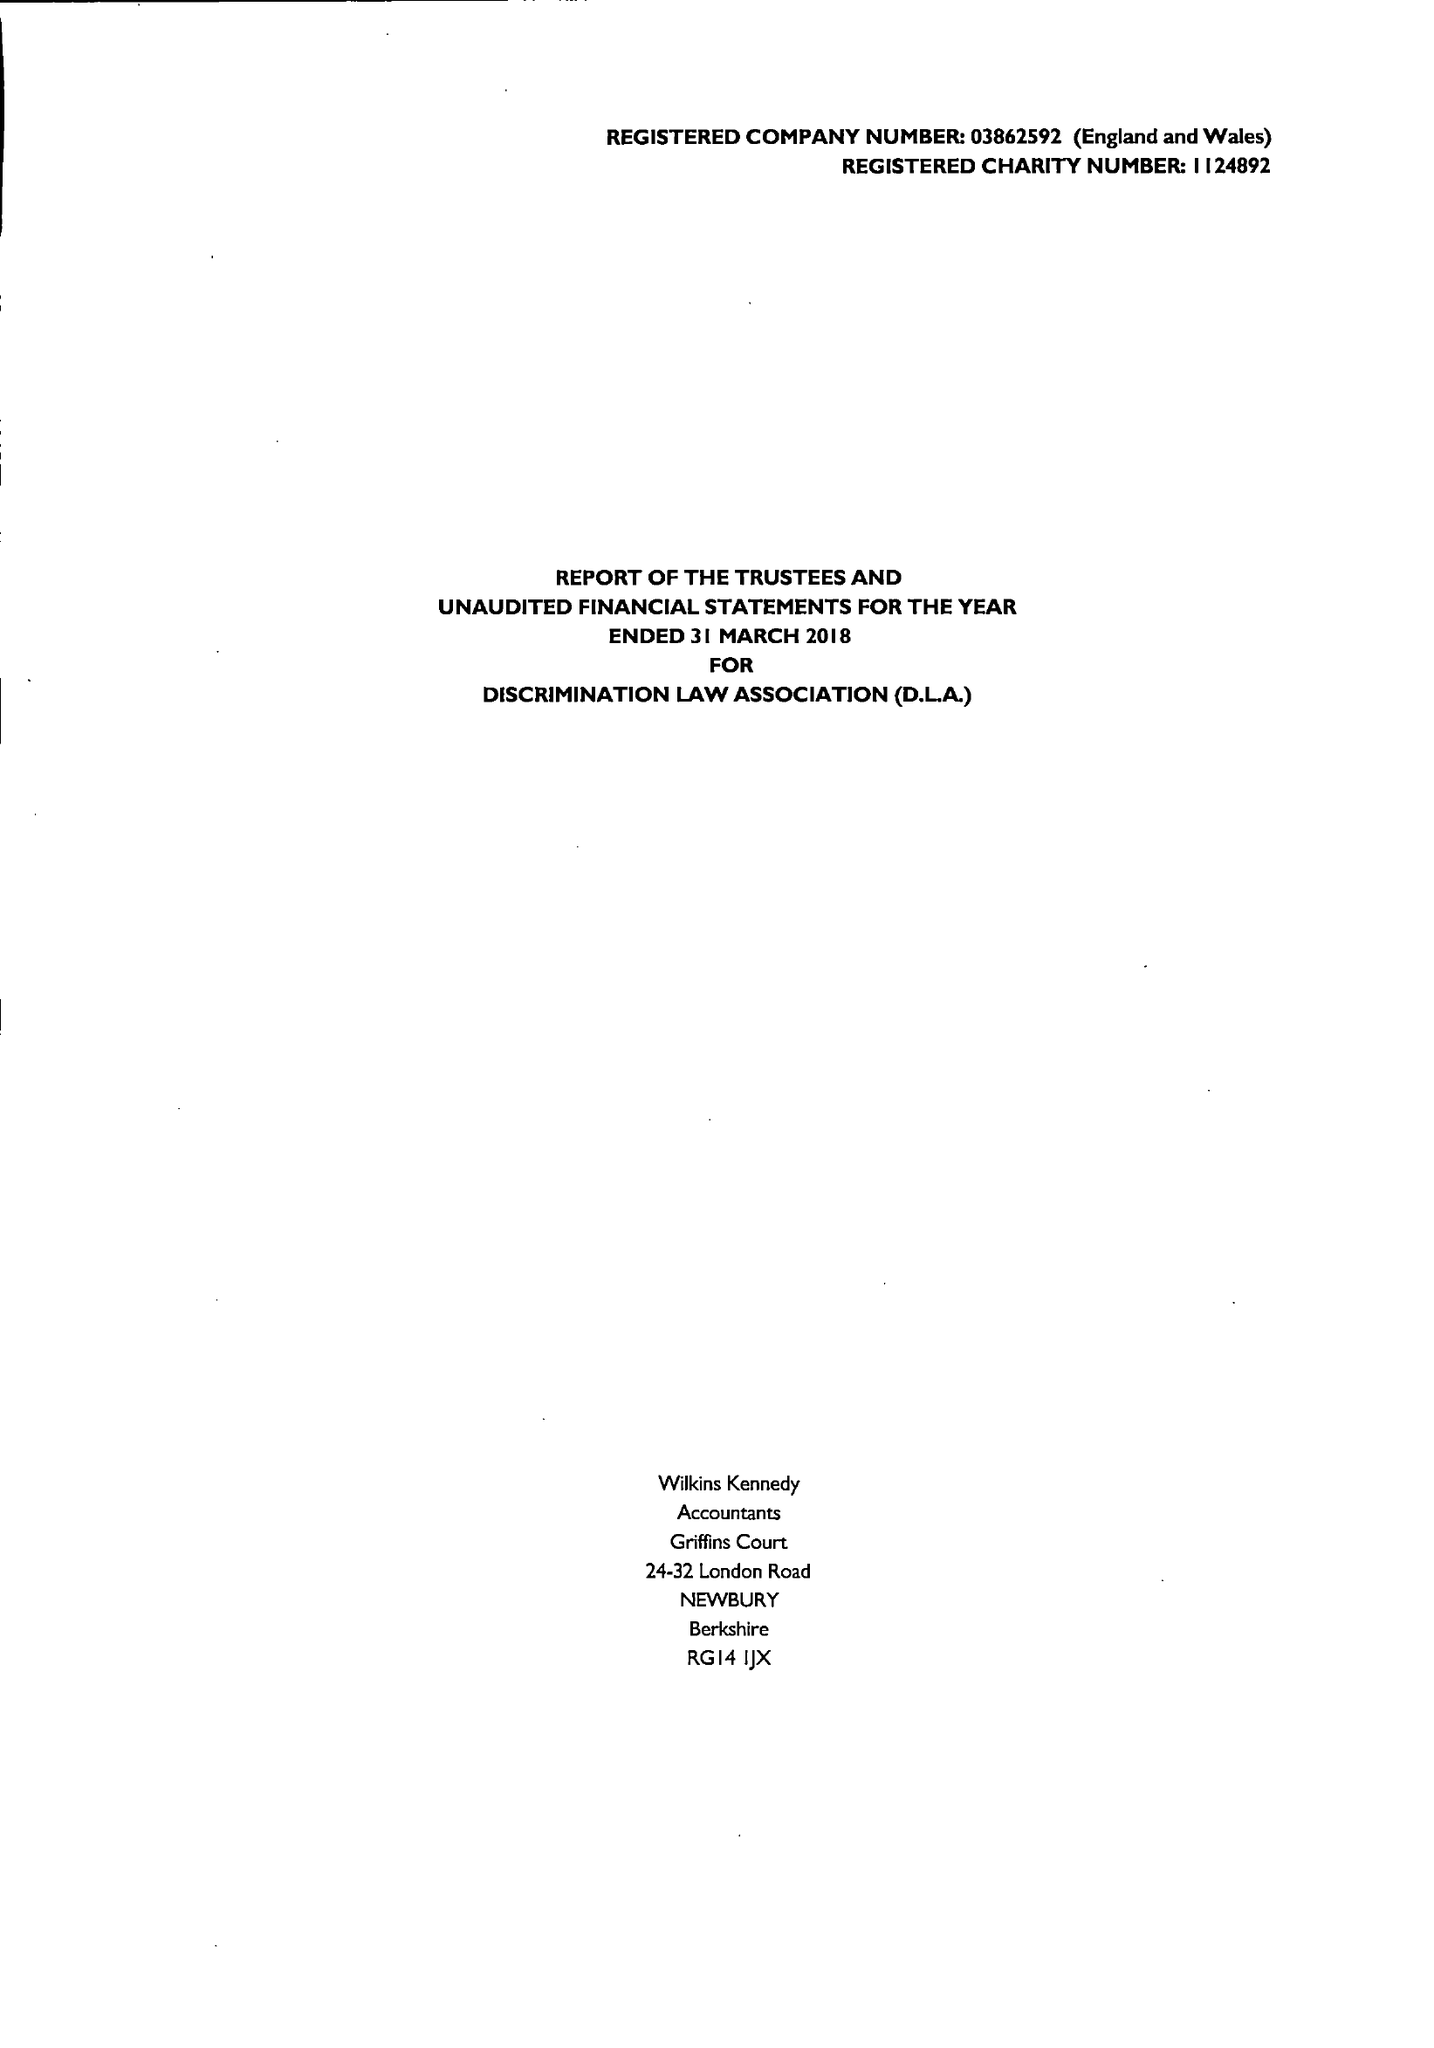What is the value for the spending_annually_in_british_pounds?
Answer the question using a single word or phrase. 28806.00 